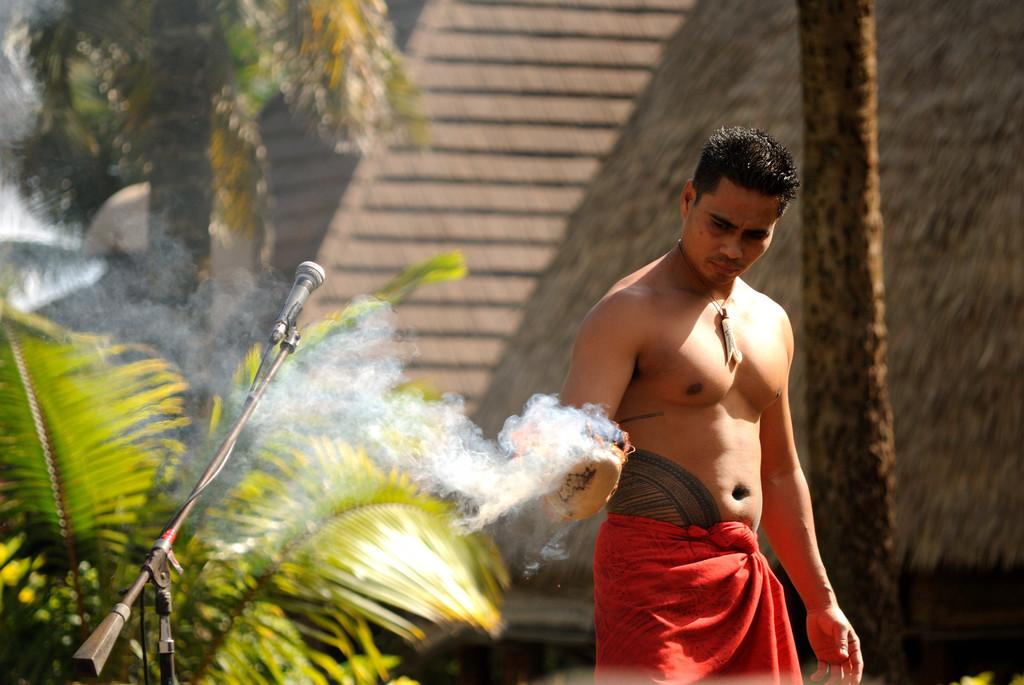Who is present in the image? There is a man in the image. What object is on the left side of the image? There is a microphone with a stand on the left side of the image. What type of natural environment can be seen in the image? Trees are visible in the image. What part of the trees can be observed in the image? The bark of the trees is visible in the image. What type of oatmeal is the man eating in the image? There is no oatmeal present in the image, and the man is not eating anything. 